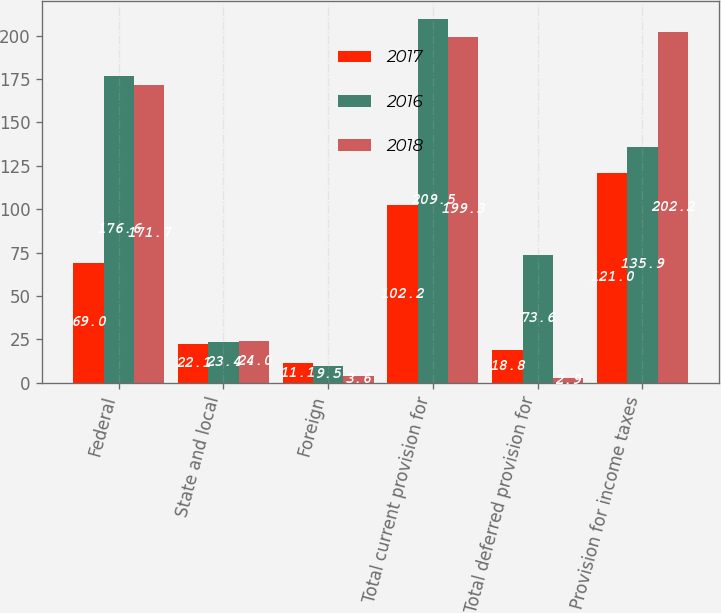<chart> <loc_0><loc_0><loc_500><loc_500><stacked_bar_chart><ecel><fcel>Federal<fcel>State and local<fcel>Foreign<fcel>Total current provision for<fcel>Total deferred provision for<fcel>Provision for income taxes<nl><fcel>2017<fcel>69<fcel>22.1<fcel>11.1<fcel>102.2<fcel>18.8<fcel>121<nl><fcel>2016<fcel>176.6<fcel>23.4<fcel>9.5<fcel>209.5<fcel>73.6<fcel>135.9<nl><fcel>2018<fcel>171.7<fcel>24<fcel>3.6<fcel>199.3<fcel>2.9<fcel>202.2<nl></chart> 